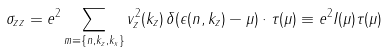Convert formula to latex. <formula><loc_0><loc_0><loc_500><loc_500>\sigma _ { z z } = e ^ { 2 } \sum _ { m \equiv \{ n , k _ { z } , k _ { x } \} } v _ { z } ^ { 2 } ( k _ { z } ) \, \delta ( \epsilon ( n , k _ { z } ) - \mu ) \cdot \tau ( \mu ) \equiv e ^ { 2 } I ( \mu ) \tau ( \mu )</formula> 